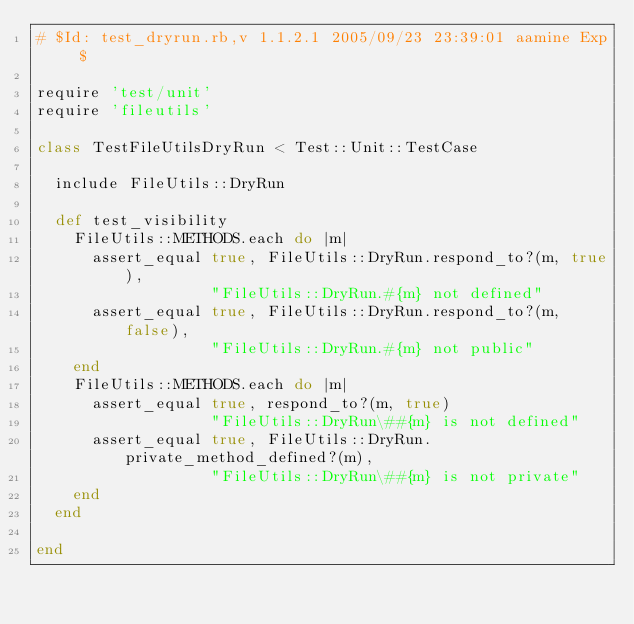Convert code to text. <code><loc_0><loc_0><loc_500><loc_500><_Ruby_># $Id: test_dryrun.rb,v 1.1.2.1 2005/09/23 23:39:01 aamine Exp $

require 'test/unit'
require 'fileutils'

class TestFileUtilsDryRun < Test::Unit::TestCase

  include FileUtils::DryRun

  def test_visibility
    FileUtils::METHODS.each do |m|
      assert_equal true, FileUtils::DryRun.respond_to?(m, true),
                   "FileUtils::DryRun.#{m} not defined"
      assert_equal true, FileUtils::DryRun.respond_to?(m, false),
                   "FileUtils::DryRun.#{m} not public"
    end
    FileUtils::METHODS.each do |m|
      assert_equal true, respond_to?(m, true)
                   "FileUtils::DryRun\##{m} is not defined"
      assert_equal true, FileUtils::DryRun.private_method_defined?(m),
                   "FileUtils::DryRun\##{m} is not private"
    end
  end

end
</code> 